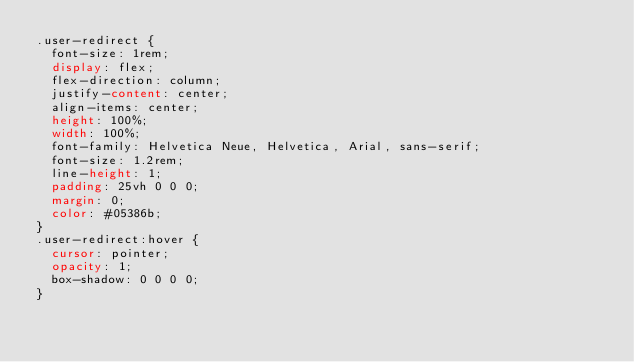Convert code to text. <code><loc_0><loc_0><loc_500><loc_500><_CSS_>.user-redirect {
  font-size: 1rem;
  display: flex;
  flex-direction: column;
  justify-content: center;
  align-items: center;
  height: 100%;
  width: 100%;
  font-family: Helvetica Neue, Helvetica, Arial, sans-serif;
  font-size: 1.2rem;
  line-height: 1;
  padding: 25vh 0 0 0;
  margin: 0;
  color: #05386b;
}
.user-redirect:hover {
  cursor: pointer;
  opacity: 1;
  box-shadow: 0 0 0 0;
}
</code> 